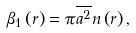<formula> <loc_0><loc_0><loc_500><loc_500>\beta _ { 1 } \left ( r \right ) = \pi \overline { a ^ { 2 } } n \left ( r \right ) ,</formula> 